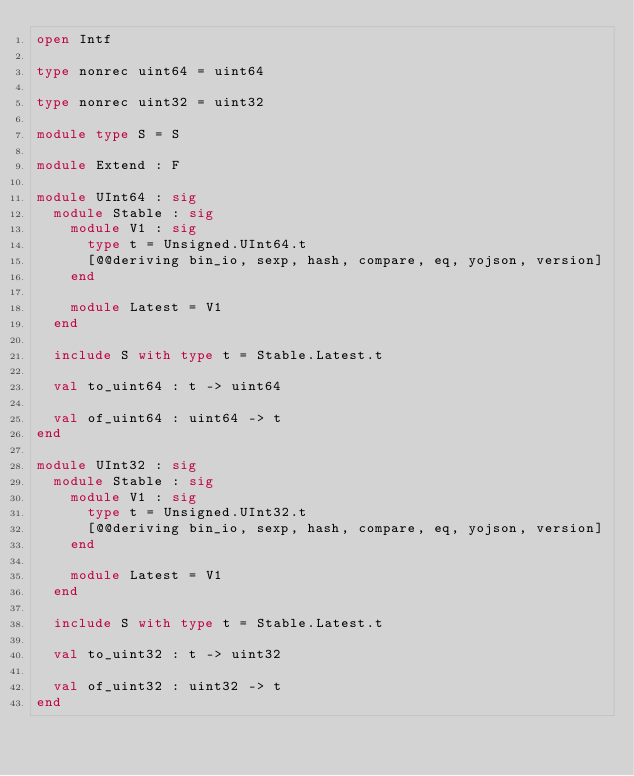<code> <loc_0><loc_0><loc_500><loc_500><_OCaml_>open Intf

type nonrec uint64 = uint64

type nonrec uint32 = uint32

module type S = S

module Extend : F

module UInt64 : sig
  module Stable : sig
    module V1 : sig
      type t = Unsigned.UInt64.t
      [@@deriving bin_io, sexp, hash, compare, eq, yojson, version]
    end

    module Latest = V1
  end

  include S with type t = Stable.Latest.t

  val to_uint64 : t -> uint64

  val of_uint64 : uint64 -> t
end

module UInt32 : sig
  module Stable : sig
    module V1 : sig
      type t = Unsigned.UInt32.t
      [@@deriving bin_io, sexp, hash, compare, eq, yojson, version]
    end

    module Latest = V1
  end

  include S with type t = Stable.Latest.t

  val to_uint32 : t -> uint32

  val of_uint32 : uint32 -> t
end
</code> 